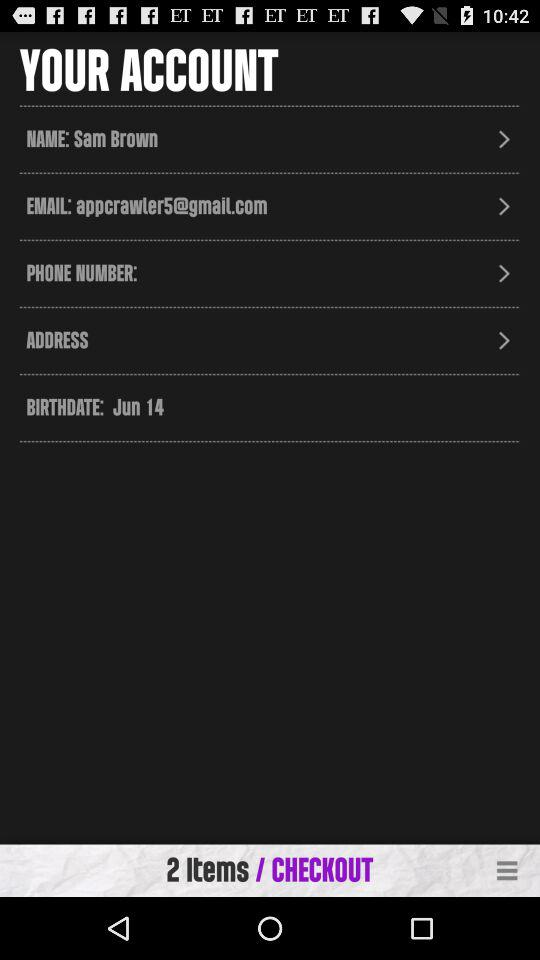What is the date of birth? The date of birth is June 14. 